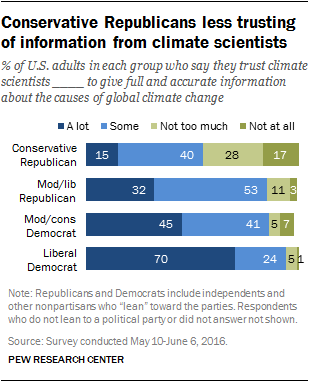Point out several critical features in this image. The ratio of the largest navy blue bar to the second smallest light blue bar is 0.294444444... Ninety percent of Liberal Democrats trust climate scientists to provide accurate information on the causes of global climate change. 